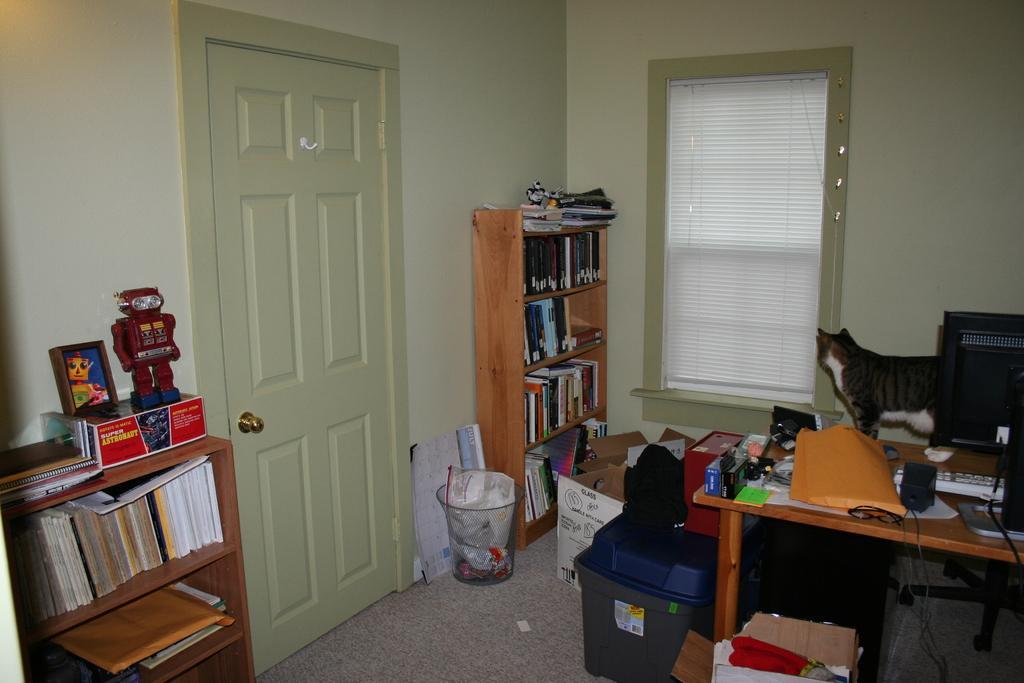Could you give a brief overview of what you see in this image? In this image we can see a cat, computer, keyboard and few things placed on the table. There is a bookshelf and toy on the left side of the image. This is door and this is the window glass. This is the dustbin and this is the cardboard box. 